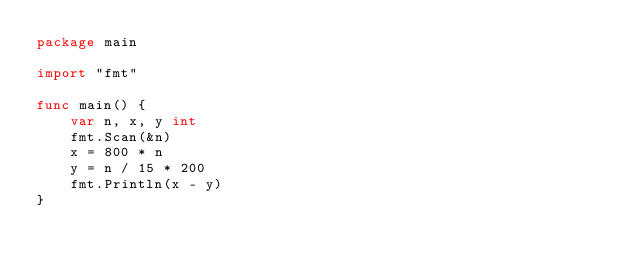Convert code to text. <code><loc_0><loc_0><loc_500><loc_500><_Go_>package main

import "fmt"

func main() {
	var n, x, y int
	fmt.Scan(&n)
	x = 800 * n
	y = n / 15 * 200
	fmt.Println(x - y)
}
</code> 